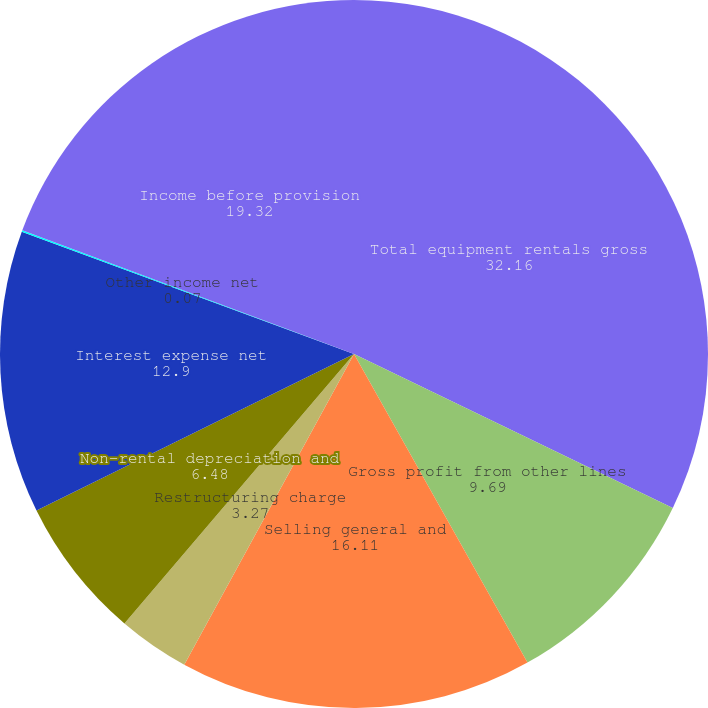Convert chart to OTSL. <chart><loc_0><loc_0><loc_500><loc_500><pie_chart><fcel>Total equipment rentals gross<fcel>Gross profit from other lines<fcel>Selling general and<fcel>Restructuring charge<fcel>Non-rental depreciation and<fcel>Interest expense net<fcel>Other income net<fcel>Income before provision<nl><fcel>32.16%<fcel>9.69%<fcel>16.11%<fcel>3.27%<fcel>6.48%<fcel>12.9%<fcel>0.07%<fcel>19.32%<nl></chart> 